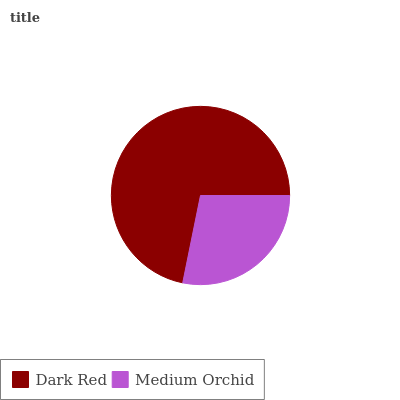Is Medium Orchid the minimum?
Answer yes or no. Yes. Is Dark Red the maximum?
Answer yes or no. Yes. Is Medium Orchid the maximum?
Answer yes or no. No. Is Dark Red greater than Medium Orchid?
Answer yes or no. Yes. Is Medium Orchid less than Dark Red?
Answer yes or no. Yes. Is Medium Orchid greater than Dark Red?
Answer yes or no. No. Is Dark Red less than Medium Orchid?
Answer yes or no. No. Is Dark Red the high median?
Answer yes or no. Yes. Is Medium Orchid the low median?
Answer yes or no. Yes. Is Medium Orchid the high median?
Answer yes or no. No. Is Dark Red the low median?
Answer yes or no. No. 